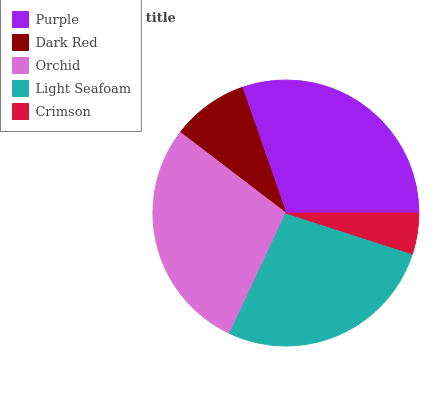Is Crimson the minimum?
Answer yes or no. Yes. Is Purple the maximum?
Answer yes or no. Yes. Is Dark Red the minimum?
Answer yes or no. No. Is Dark Red the maximum?
Answer yes or no. No. Is Purple greater than Dark Red?
Answer yes or no. Yes. Is Dark Red less than Purple?
Answer yes or no. Yes. Is Dark Red greater than Purple?
Answer yes or no. No. Is Purple less than Dark Red?
Answer yes or no. No. Is Light Seafoam the high median?
Answer yes or no. Yes. Is Light Seafoam the low median?
Answer yes or no. Yes. Is Crimson the high median?
Answer yes or no. No. Is Orchid the low median?
Answer yes or no. No. 